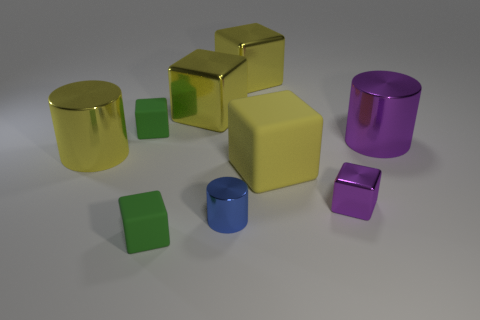How many green cubes must be subtracted to get 1 green cubes? 1 Subtract all gray cylinders. How many yellow blocks are left? 3 Subtract all purple blocks. How many blocks are left? 5 Subtract all small purple metal blocks. How many blocks are left? 5 Subtract all brown cubes. Subtract all yellow cylinders. How many cubes are left? 6 Add 1 blue shiny things. How many objects exist? 10 Subtract all cylinders. How many objects are left? 6 Add 7 small cylinders. How many small cylinders exist? 8 Subtract 0 green balls. How many objects are left? 9 Subtract all large green shiny balls. Subtract all small rubber cubes. How many objects are left? 7 